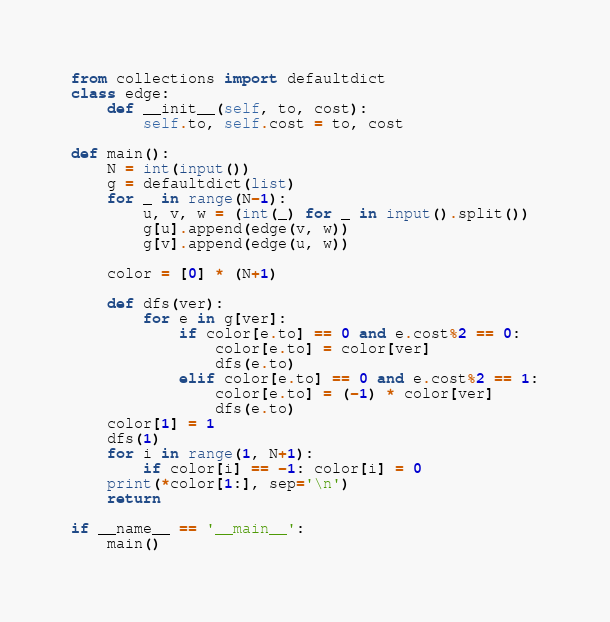Convert code to text. <code><loc_0><loc_0><loc_500><loc_500><_Python_>from collections import defaultdict
class edge:
    def __init__(self, to, cost):
        self.to, self.cost = to, cost

def main():
    N = int(input())
    g = defaultdict(list)
    for _ in range(N-1):
        u, v, w = (int(_) for _ in input().split())
        g[u].append(edge(v, w))
        g[v].append(edge(u, w))

    color = [0] * (N+1)

    def dfs(ver):
        for e in g[ver]:
            if color[e.to] == 0 and e.cost%2 == 0:
                color[e.to] = color[ver]
                dfs(e.to)
            elif color[e.to] == 0 and e.cost%2 == 1:
                color[e.to] = (-1) * color[ver]
                dfs(e.to)
    color[1] = 1
    dfs(1)
    for i in range(1, N+1):
        if color[i] == -1: color[i] = 0
    print(*color[1:], sep='\n')
    return

if __name__ == '__main__':
    main()
</code> 